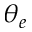Convert formula to latex. <formula><loc_0><loc_0><loc_500><loc_500>\theta _ { e }</formula> 